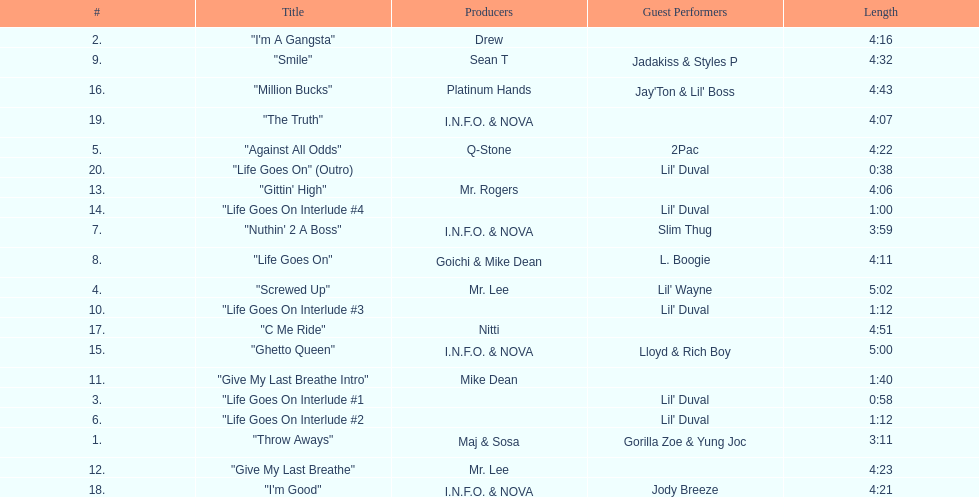Which tracks feature the same producer(s) in consecutive order on this album? "I'm Good", "The Truth". 